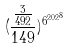Convert formula to latex. <formula><loc_0><loc_0><loc_500><loc_500>( \frac { \frac { 3 } { 4 9 2 } } { 1 4 9 } ) ^ { { 6 ^ { 2 0 2 } } ^ { 8 } }</formula> 